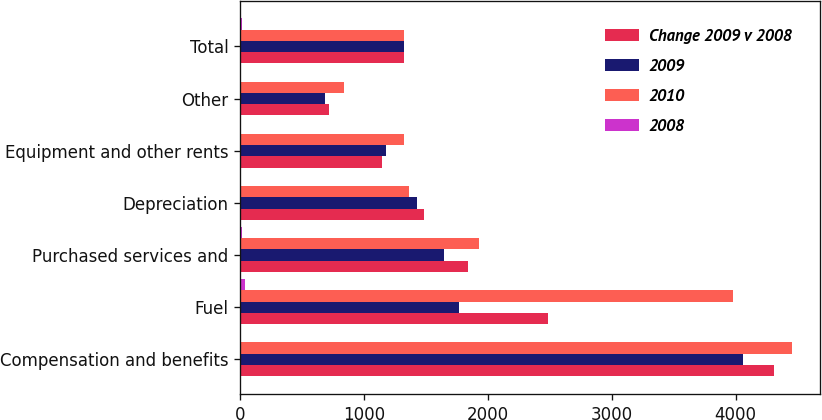Convert chart. <chart><loc_0><loc_0><loc_500><loc_500><stacked_bar_chart><ecel><fcel>Compensation and benefits<fcel>Fuel<fcel>Purchased services and<fcel>Depreciation<fcel>Equipment and other rents<fcel>Other<fcel>Total<nl><fcel>Change 2009 v 2008<fcel>4314<fcel>2486<fcel>1836<fcel>1487<fcel>1142<fcel>719<fcel>1326<nl><fcel>2009<fcel>4063<fcel>1763<fcel>1644<fcel>1427<fcel>1180<fcel>687<fcel>1326<nl><fcel>2010<fcel>4457<fcel>3983<fcel>1928<fcel>1366<fcel>1326<fcel>840<fcel>1326<nl><fcel>2008<fcel>6<fcel>41<fcel>12<fcel>4<fcel>3<fcel>5<fcel>11<nl></chart> 